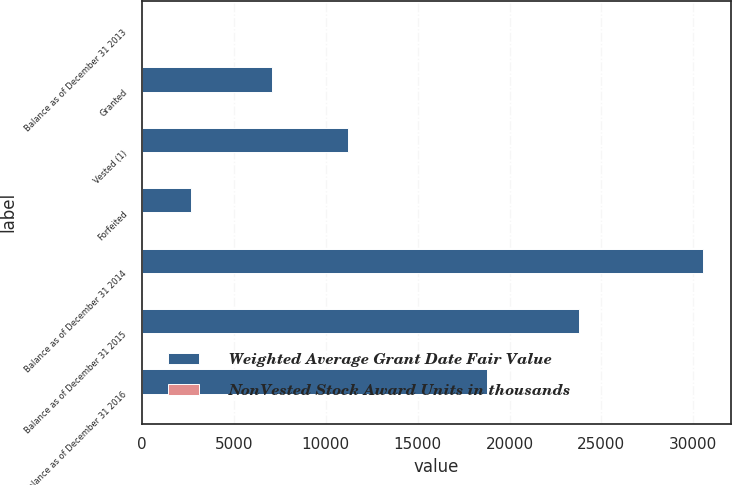Convert chart. <chart><loc_0><loc_0><loc_500><loc_500><stacked_bar_chart><ecel><fcel>Balance as of December 31 2013<fcel>Granted<fcel>Vested (1)<fcel>Forfeited<fcel>Balance as of December 31 2014<fcel>Balance as of December 31 2015<fcel>Balance as of December 31 2016<nl><fcel>Weighted Average Grant Date Fair Value<fcel>14<fcel>7072<fcel>11205<fcel>2671<fcel>30535<fcel>23764<fcel>18797<nl><fcel>NonVested Stock Award Units in thousands<fcel>7<fcel>13<fcel>7<fcel>8<fcel>9<fcel>11<fcel>14<nl></chart> 